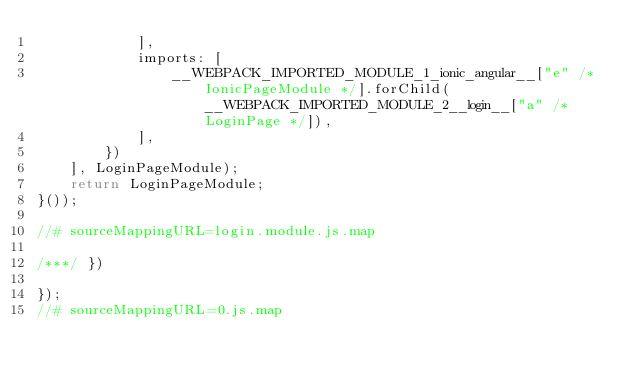Convert code to text. <code><loc_0><loc_0><loc_500><loc_500><_JavaScript_>            ],
            imports: [
                __WEBPACK_IMPORTED_MODULE_1_ionic_angular__["e" /* IonicPageModule */].forChild(__WEBPACK_IMPORTED_MODULE_2__login__["a" /* LoginPage */]),
            ],
        })
    ], LoginPageModule);
    return LoginPageModule;
}());

//# sourceMappingURL=login.module.js.map

/***/ })

});
//# sourceMappingURL=0.js.map</code> 